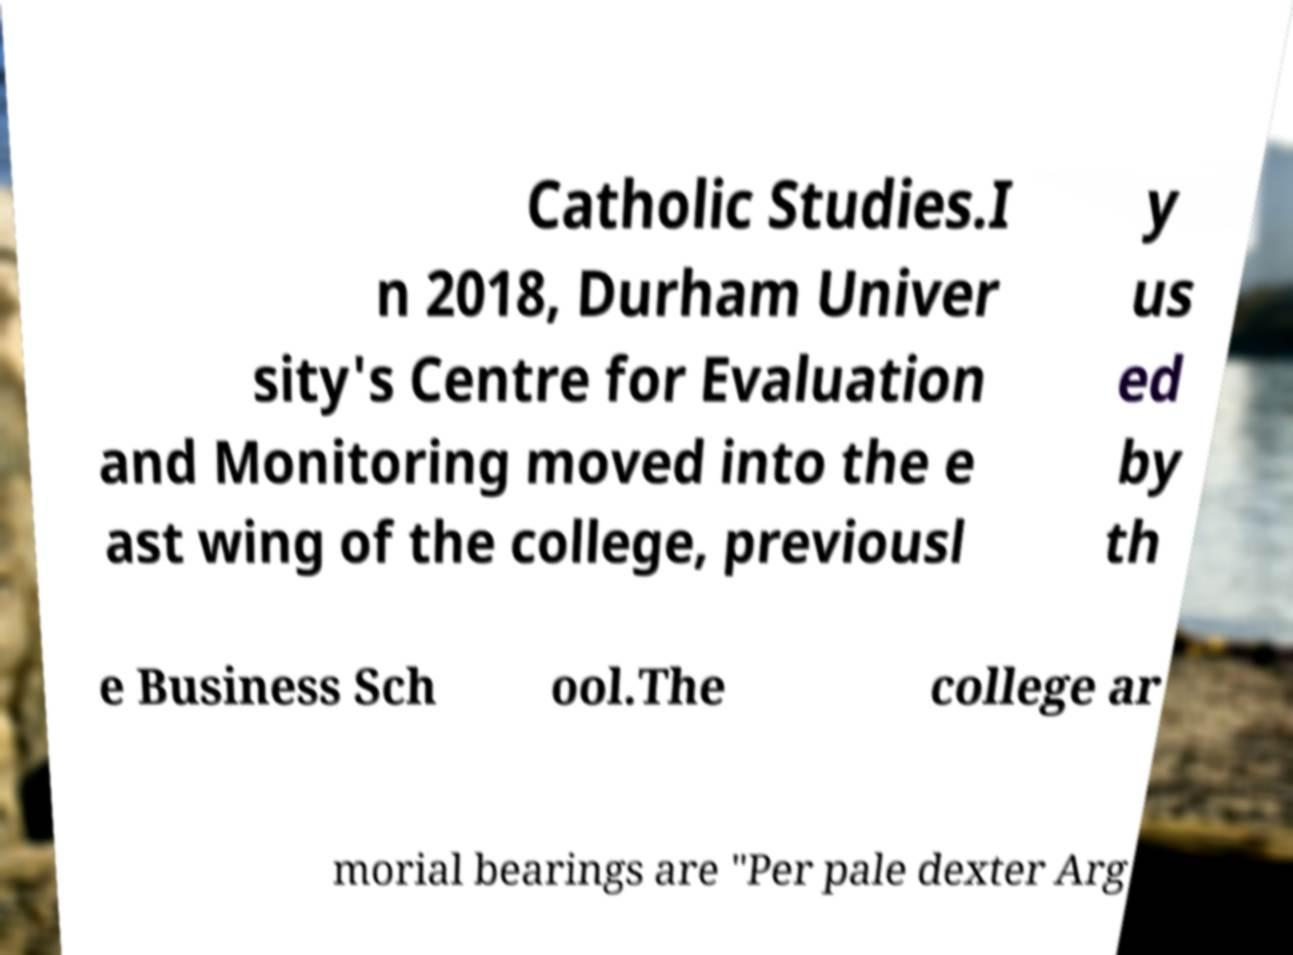What messages or text are displayed in this image? I need them in a readable, typed format. Catholic Studies.I n 2018, Durham Univer sity's Centre for Evaluation and Monitoring moved into the e ast wing of the college, previousl y us ed by th e Business Sch ool.The college ar morial bearings are "Per pale dexter Arg 